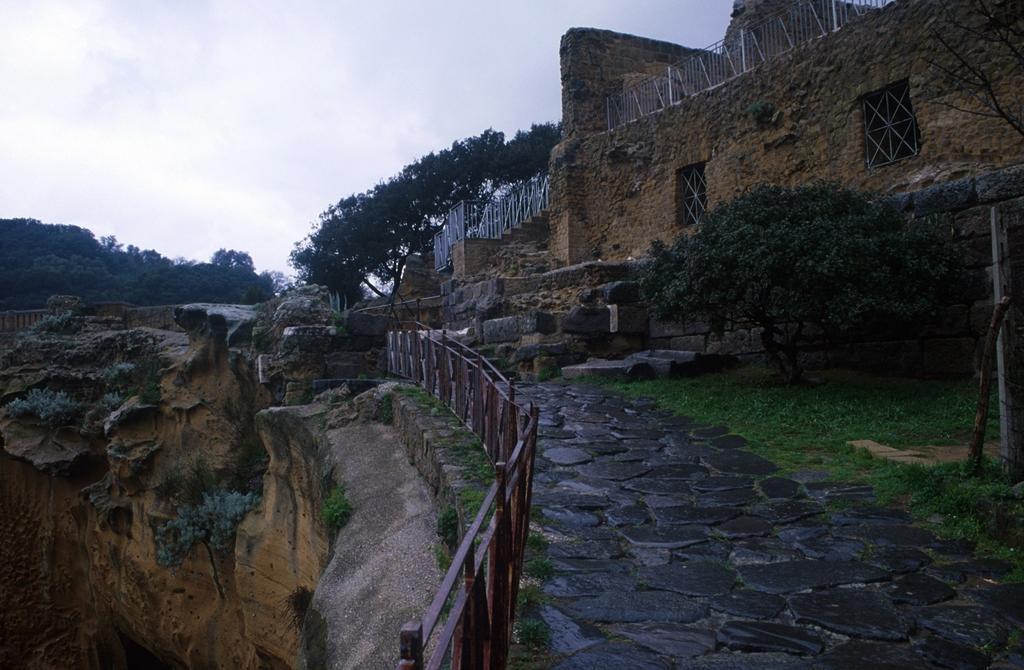How would you summarize this image in a sentence or two? In this image we can see a fort with the windows, grills, and a wall, there are some trees, grass and in the background there is a sky. 